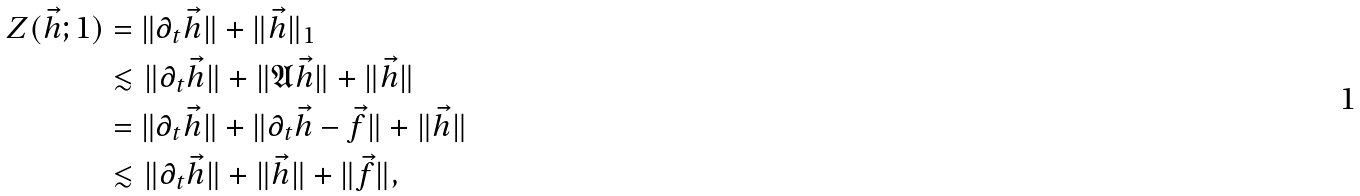Convert formula to latex. <formula><loc_0><loc_0><loc_500><loc_500>Z ( \vec { h } ; 1 ) & = \| \partial _ { t } \vec { h } \| + \| \vec { h } \| _ { 1 } \\ & \lesssim \| \partial _ { t } \vec { h } \| + \| \mathfrak { A } \vec { h } \| + \| \vec { h } \| \\ & = \| \partial _ { t } \vec { h } \| + \| \partial _ { t } \vec { h } - \vec { f } \| + \| \vec { h } \| \\ & \lesssim \| \partial _ { t } \vec { h } \| + \| \vec { h } \| + \| \vec { f } \| ,</formula> 